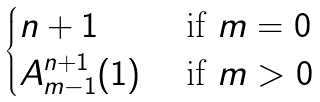Convert formula to latex. <formula><loc_0><loc_0><loc_500><loc_500>\begin{cases} n + 1 & \text { if } m = 0 \\ A _ { m - 1 } ^ { n + 1 } ( 1 ) & \text { if } m > 0 \\ \end{cases}</formula> 